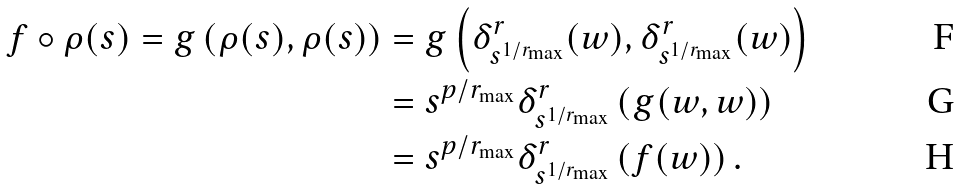<formula> <loc_0><loc_0><loc_500><loc_500>f \circ \rho ( s ) = g \left ( \rho ( s ) , \rho ( s ) \right ) & = g \left ( \delta ^ { r } _ { s ^ { 1 / r _ { \max } } } ( w ) , \delta ^ { r } _ { s ^ { 1 / r _ { \max } } } ( w ) \right ) \\ & = s ^ { p / r _ { \max } } \delta ^ { r } _ { s ^ { 1 / r _ { \max } } } \left ( g ( w , w ) \right ) \\ & = s ^ { p / r _ { \max } } \delta ^ { r } _ { s ^ { 1 / r _ { \max } } } \left ( f ( w ) \right ) .</formula> 